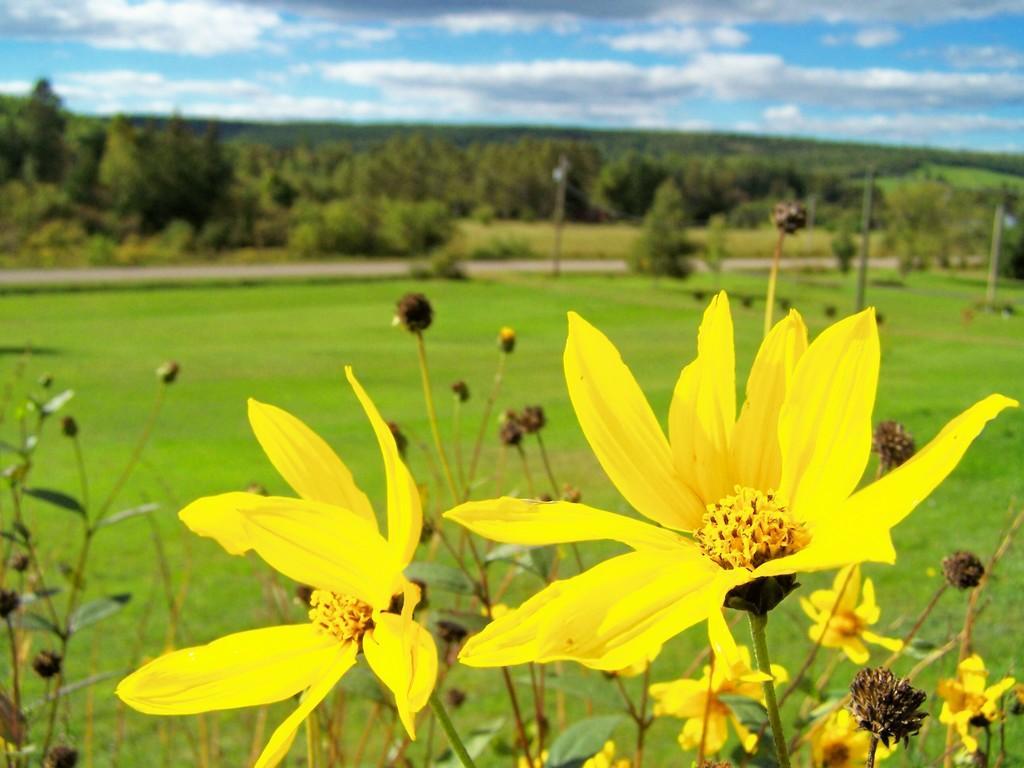In one or two sentences, can you explain what this image depicts? In this image there are plants for that plants there are flowers and buds, in the background there is grassland, road, trees and the sky and it is blurred. 